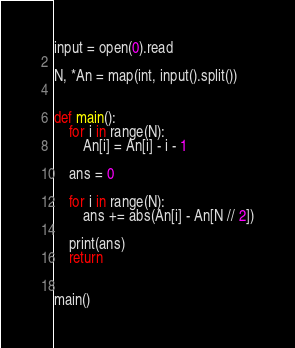Convert code to text. <code><loc_0><loc_0><loc_500><loc_500><_Python_>input = open(0).read

N, *An = map(int, input().split())


def main():
    for i in range(N):
        An[i] = An[i] - i - 1

    ans = 0

    for i in range(N):
        ans += abs(An[i] - An[N // 2])

    print(ans)
    return


main()
</code> 